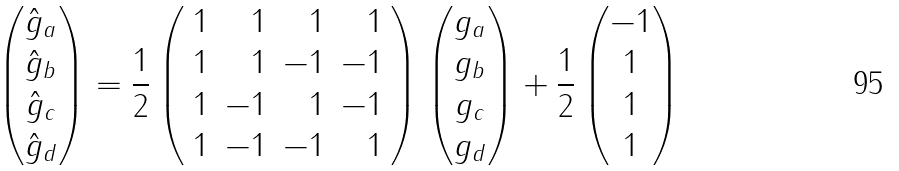<formula> <loc_0><loc_0><loc_500><loc_500>\left ( \begin{matrix} \hat { g } _ { a } \\ \hat { g } _ { b } \\ \hat { g } _ { c } \\ \hat { g } _ { d } \end{matrix} \right ) = \frac { 1 } { 2 } \left ( \begin{array} { r r r r } 1 & 1 & 1 & 1 \\ 1 & 1 & - 1 & - 1 \\ 1 & - 1 & 1 & - 1 \\ 1 & - 1 & - 1 & 1 \end{array} \right ) \left ( \begin{matrix} g _ { a } \\ g _ { b } \\ g _ { c } \\ g _ { d } \end{matrix} \right ) + \frac { 1 } { 2 } \left ( \begin{matrix} - 1 \\ 1 \\ 1 \\ 1 \end{matrix} \right )</formula> 